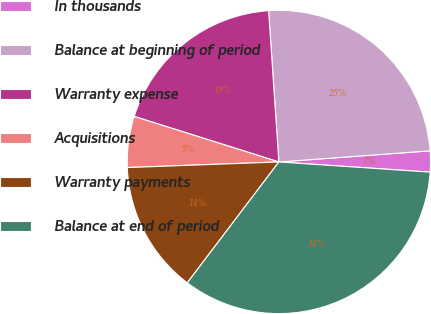Convert chart. <chart><loc_0><loc_0><loc_500><loc_500><pie_chart><fcel>In thousands<fcel>Balance at beginning of period<fcel>Warranty expense<fcel>Acquisitions<fcel>Warranty payments<fcel>Balance at end of period<nl><fcel>2.24%<fcel>24.91%<fcel>19.07%<fcel>5.44%<fcel>14.09%<fcel>34.25%<nl></chart> 